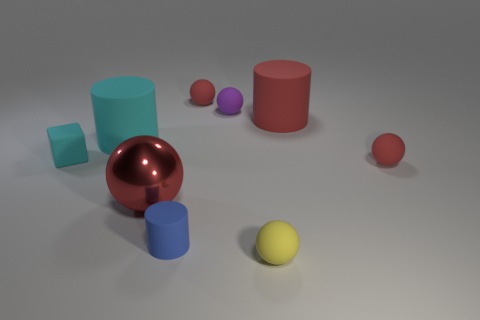Subtract all red spheres. How many were subtracted if there are1red spheres left? 2 Subtract all brown cubes. How many red balls are left? 3 Add 1 tiny red spheres. How many objects exist? 10 Subtract all purple balls. Subtract all green cubes. How many balls are left? 4 Subtract all cylinders. How many objects are left? 6 Add 4 cyan rubber blocks. How many cyan rubber blocks are left? 5 Add 6 big rubber objects. How many big rubber objects exist? 8 Subtract 0 purple cylinders. How many objects are left? 9 Subtract all tiny metallic blocks. Subtract all blue things. How many objects are left? 8 